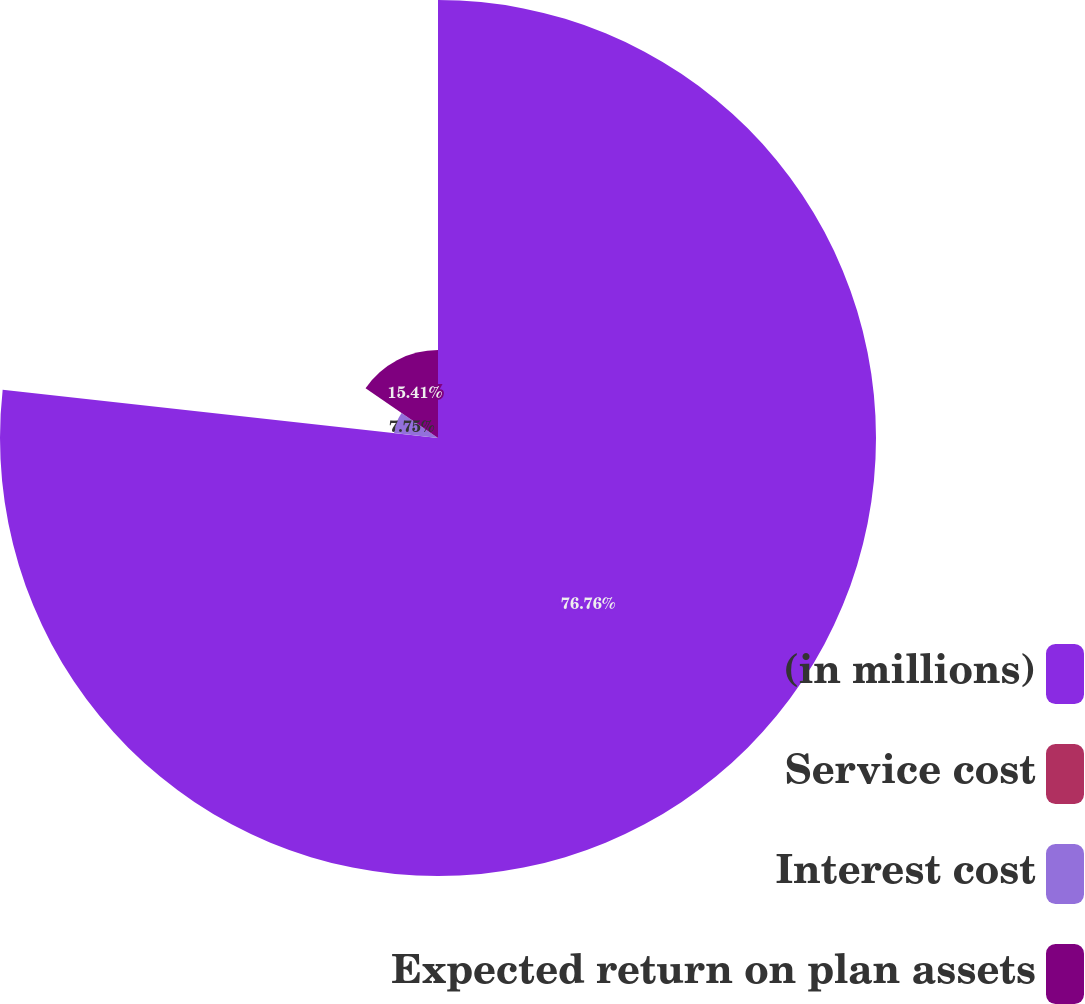Convert chart to OTSL. <chart><loc_0><loc_0><loc_500><loc_500><pie_chart><fcel>(in millions)<fcel>Service cost<fcel>Interest cost<fcel>Expected return on plan assets<nl><fcel>76.76%<fcel>0.08%<fcel>7.75%<fcel>15.41%<nl></chart> 